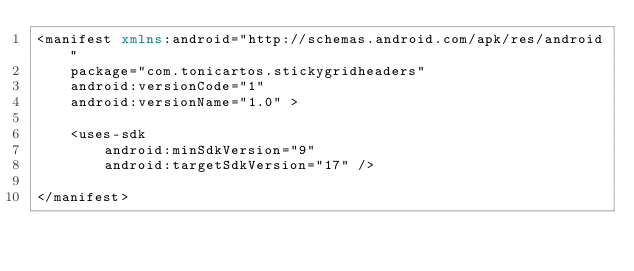<code> <loc_0><loc_0><loc_500><loc_500><_XML_><manifest xmlns:android="http://schemas.android.com/apk/res/android"
    package="com.tonicartos.stickygridheaders"
    android:versionCode="1"
    android:versionName="1.0" >

    <uses-sdk
        android:minSdkVersion="9"
        android:targetSdkVersion="17" />

</manifest></code> 